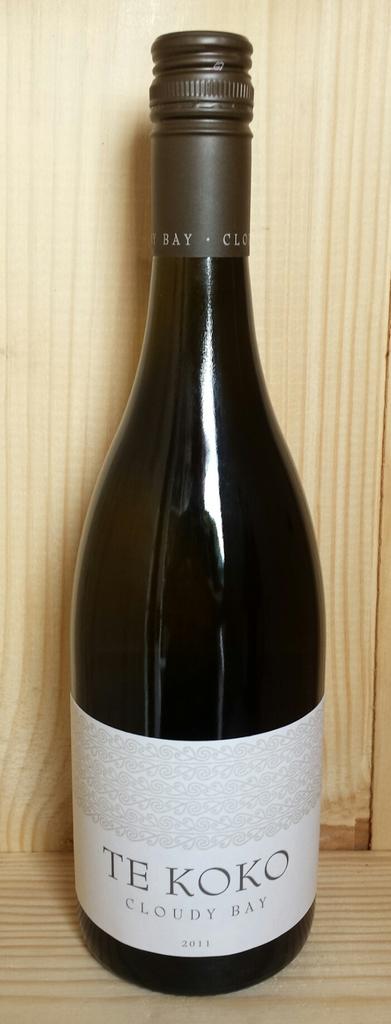What is the name of this wine?
Your answer should be compact. Te koko. When was this wine made?
Provide a short and direct response. 2011. 